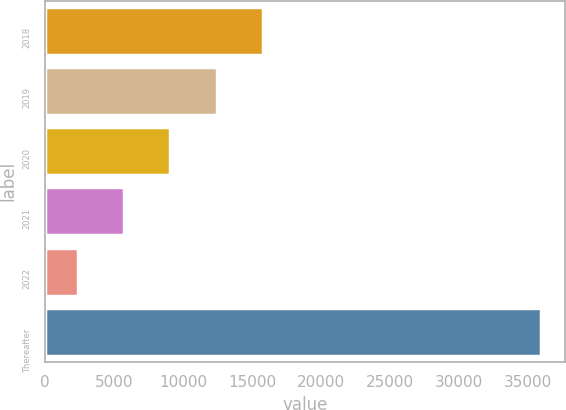<chart> <loc_0><loc_0><loc_500><loc_500><bar_chart><fcel>2018<fcel>2019<fcel>2020<fcel>2021<fcel>2022<fcel>Thereafter<nl><fcel>15780.6<fcel>12430.7<fcel>9080.8<fcel>5730.9<fcel>2381<fcel>35880<nl></chart> 